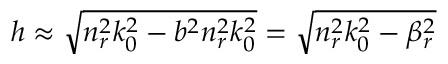Convert formula to latex. <formula><loc_0><loc_0><loc_500><loc_500>h \approx \sqrt { n _ { r } ^ { 2 } k _ { 0 } ^ { 2 } - b ^ { 2 } n _ { r } ^ { 2 } k _ { 0 } ^ { 2 } } = \sqrt { n _ { r } ^ { 2 } k _ { 0 } ^ { 2 } - \beta _ { r } ^ { 2 } }</formula> 